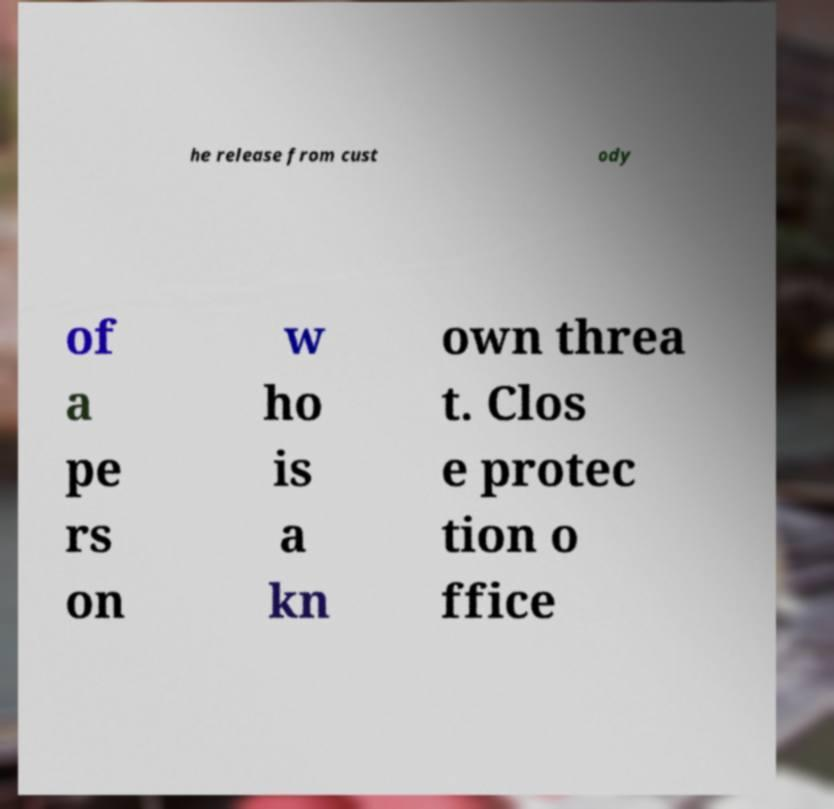Could you extract and type out the text from this image? he release from cust ody of a pe rs on w ho is a kn own threa t. Clos e protec tion o ffice 